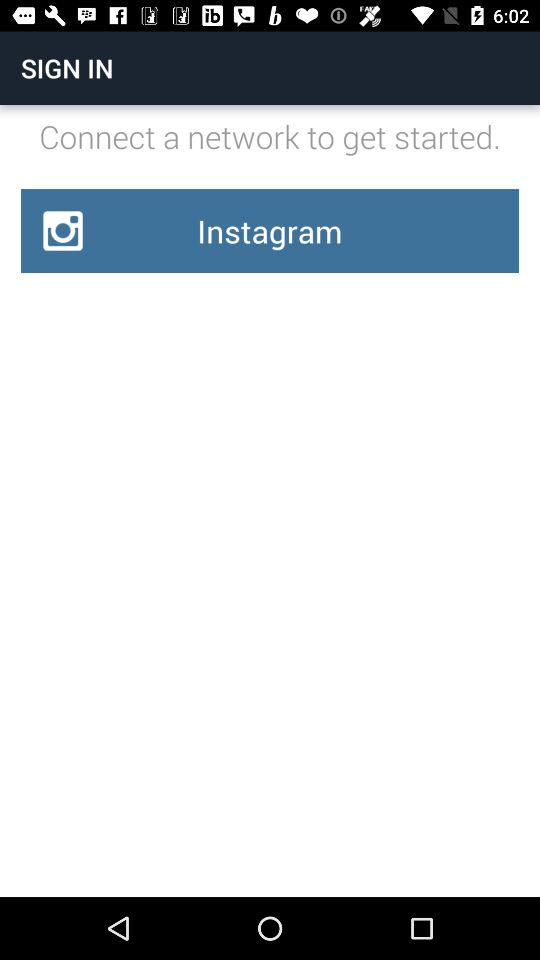What is the application name?
When the provided information is insufficient, respond with <no answer>. <no answer> 